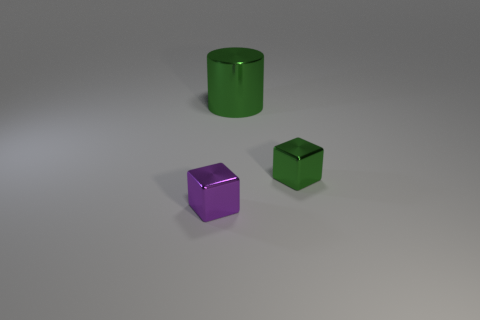Add 3 green balls. How many objects exist? 6 Subtract all blocks. How many objects are left? 1 Add 2 purple cubes. How many purple cubes are left? 3 Add 1 small shiny blocks. How many small shiny blocks exist? 3 Subtract 0 gray cubes. How many objects are left? 3 Subtract all large yellow objects. Subtract all green metallic cubes. How many objects are left? 2 